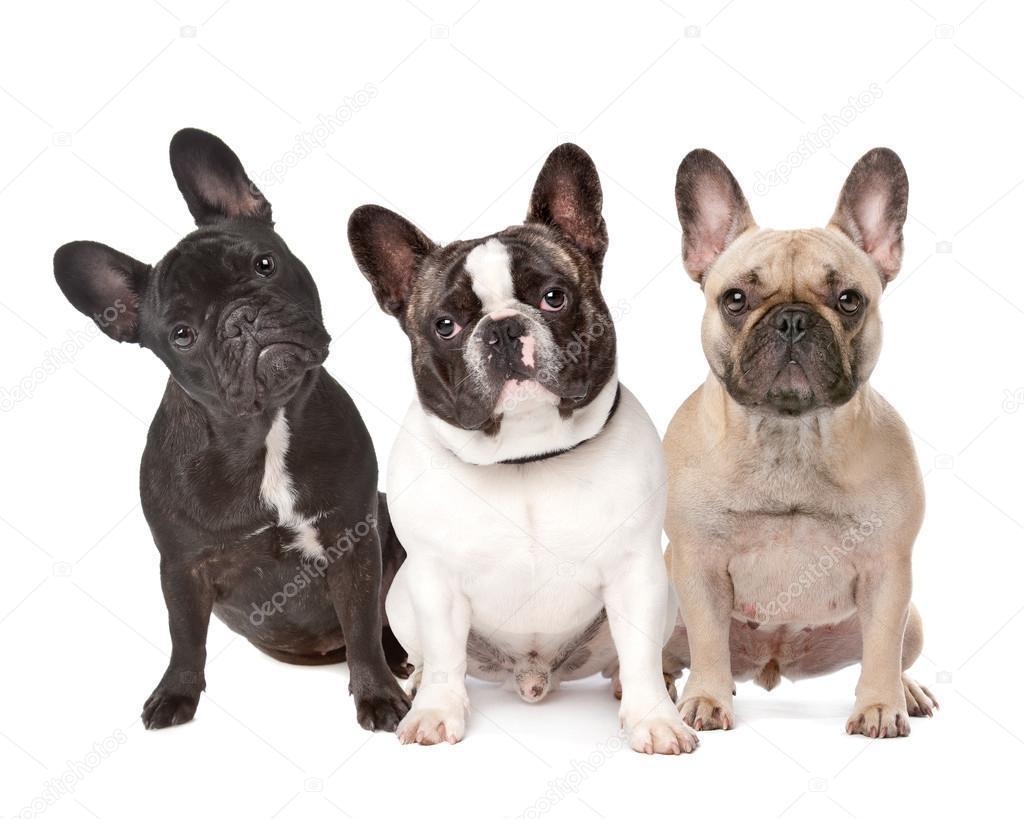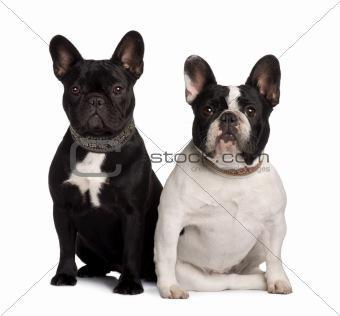The first image is the image on the left, the second image is the image on the right. Examine the images to the left and right. Is the description "An image contains exactly two side-by-side dogs, with a black one on the left and a white-bodied dog on the right." accurate? Answer yes or no. Yes. The first image is the image on the left, the second image is the image on the right. Given the left and right images, does the statement "The left image contains exactly two dogs that are seated next to each other." hold true? Answer yes or no. No. 